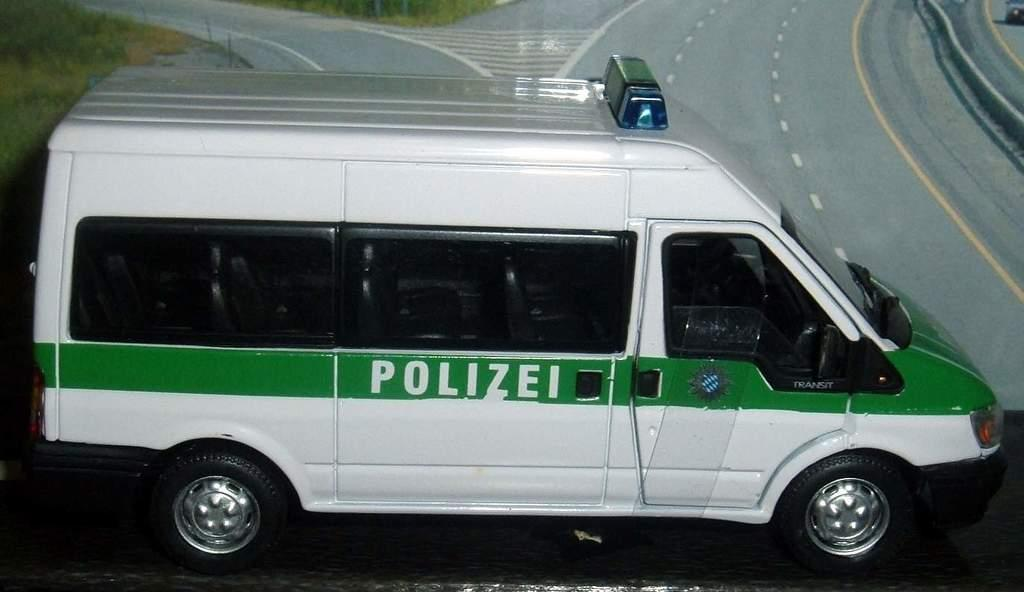<image>
Create a compact narrative representing the image presented. a white van with a green stripe, saying Polizei, is nearing the road 